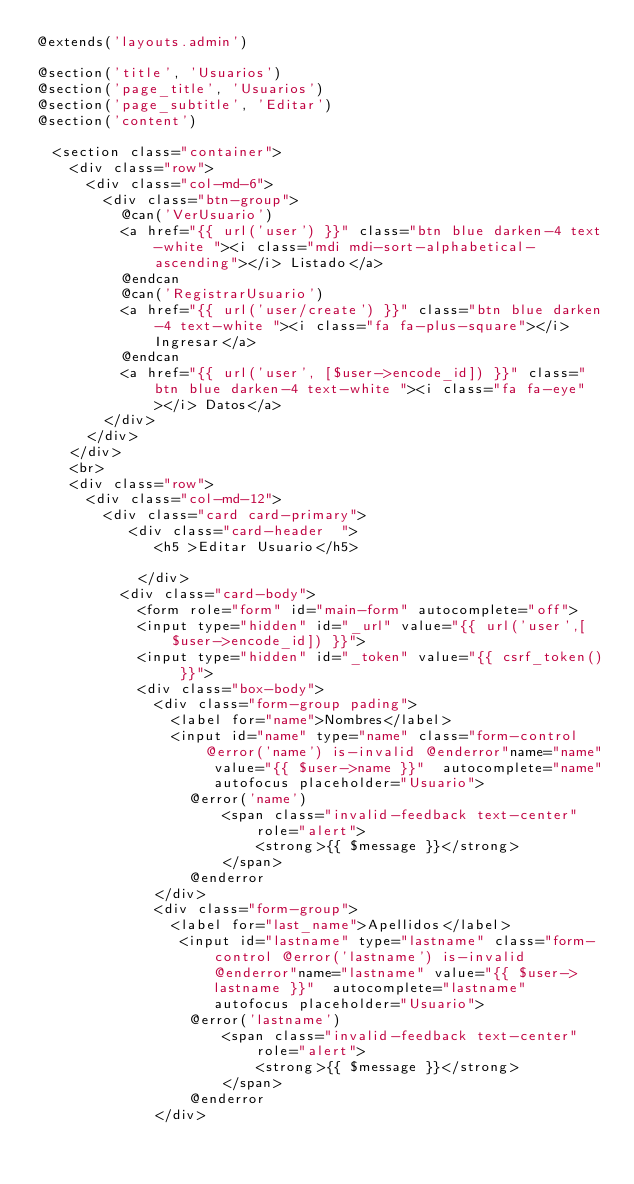<code> <loc_0><loc_0><loc_500><loc_500><_PHP_>@extends('layouts.admin')

@section('title', 'Usuarios')
@section('page_title', 'Usuarios')
@section('page_subtitle', 'Editar')
@section('content')

  <section class="container">
    <div class="row">
      <div class="col-md-6">
        <div class="btn-group">
          @can('VerUsuario')
          <a href="{{ url('user') }}" class="btn blue darken-4 text-white "><i class="mdi mdi-sort-alphabetical-ascending"></i> Listado</a>
          @endcan
          @can('RegistrarUsuario')
          <a href="{{ url('user/create') }}" class="btn blue darken-4 text-white "><i class="fa fa-plus-square"></i> Ingresar</a>
          @endcan
          <a href="{{ url('user', [$user->encode_id]) }}" class="btn blue darken-4 text-white "><i class="fa fa-eye"></i> Datos</a>
        </div>
      </div>
    </div>
    <br>
    <div class="row">
      <div class="col-md-12">
        <div class="card card-primary">
           <div class="card-header  ">
              <h5 >Editar Usuario</h5>
             
            </div>
          <div class="card-body">
            <form role="form" id="main-form" autocomplete="off">
            <input type="hidden" id="_url" value="{{ url('user',[$user->encode_id]) }}">
            <input type="hidden" id="_token" value="{{ csrf_token() }}">   
            <div class="box-body">
              <div class="form-group pading">
                <label for="name">Nombres</label>
                <input id="name" type="name" class="form-control @error('name') is-invalid @enderror"name="name" value="{{ $user->name }}"  autocomplete="name" autofocus placeholder="Usuario">
                  @error('name')
                      <span class="invalid-feedback text-center" role="alert">
                          <strong>{{ $message }}</strong>
                      </span>
                  @enderror
              </div>
              <div class="form-group">
                <label for="last_name">Apellidos</label>
                 <input id="lastname" type="lastname" class="form-control @error('lastname') is-invalid @enderror"name="lastname" value="{{ $user->lastname }}"  autocomplete="lastname" autofocus placeholder="Usuario">
                  @error('lastname')
                      <span class="invalid-feedback text-center" role="alert">
                          <strong>{{ $message }}</strong>
                      </span>
                  @enderror
              </div></code> 